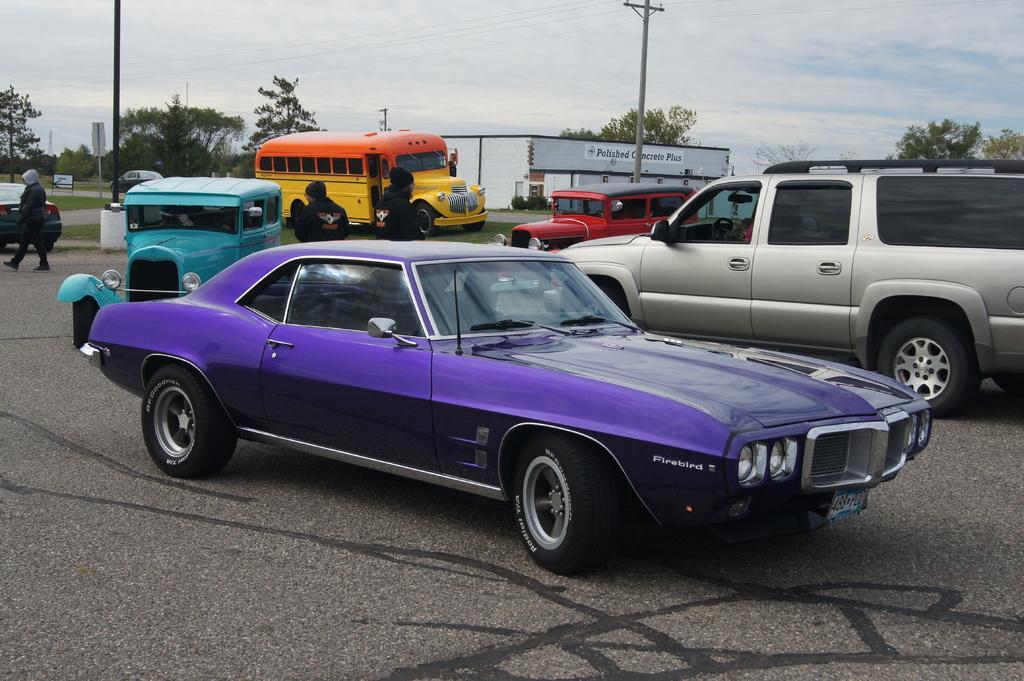Describe this image in one or two sentences. In the foreground, I can see fleets of vehicles on the road and a group of people. In the background, I can see grass, light poles, buildings, trees, sign boards and the sky. This picture might be taken on the road. 